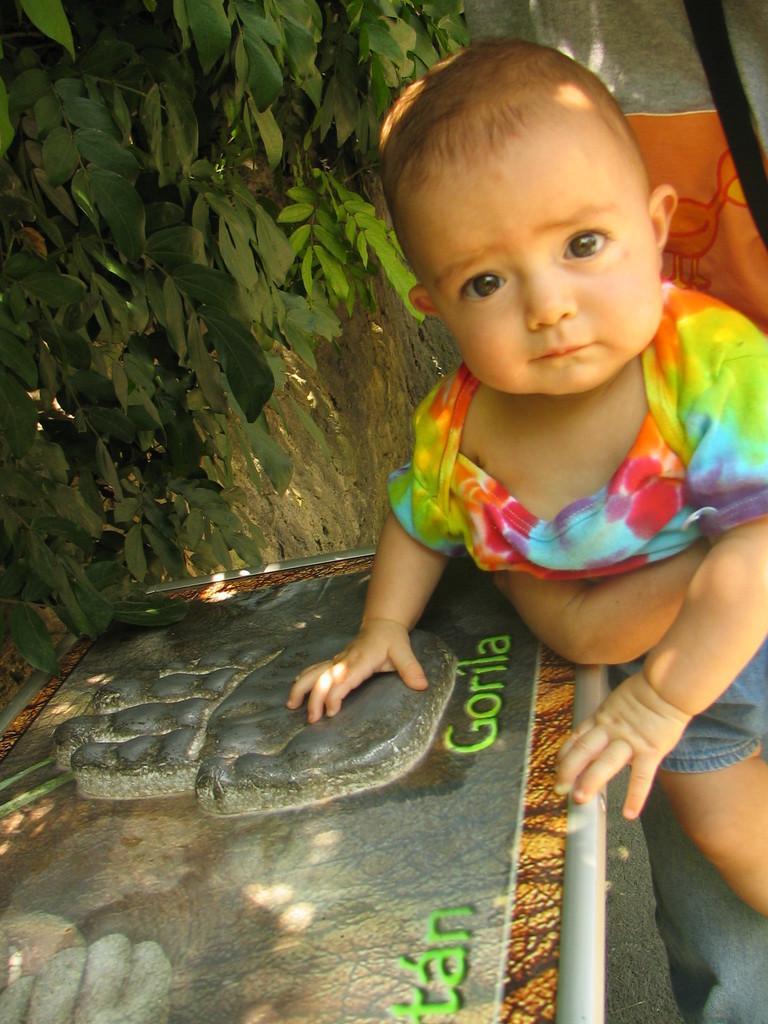Please provide a concise description of this image. On the right side of the image we can see a person is holding a kid. At the bottom of the image we can see board, floor. In the background of the image we can see tree, cloth. 